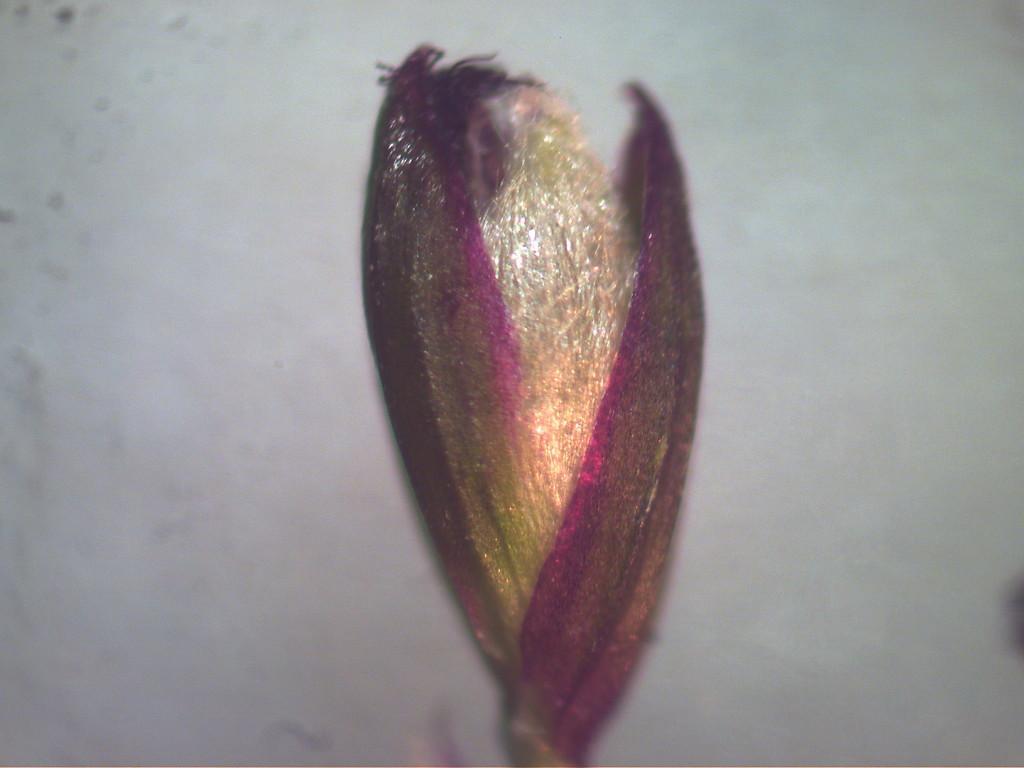Describe this image in one or two sentences. In the center of the image we can see a flower bud. In the background of the image there is a wall. 